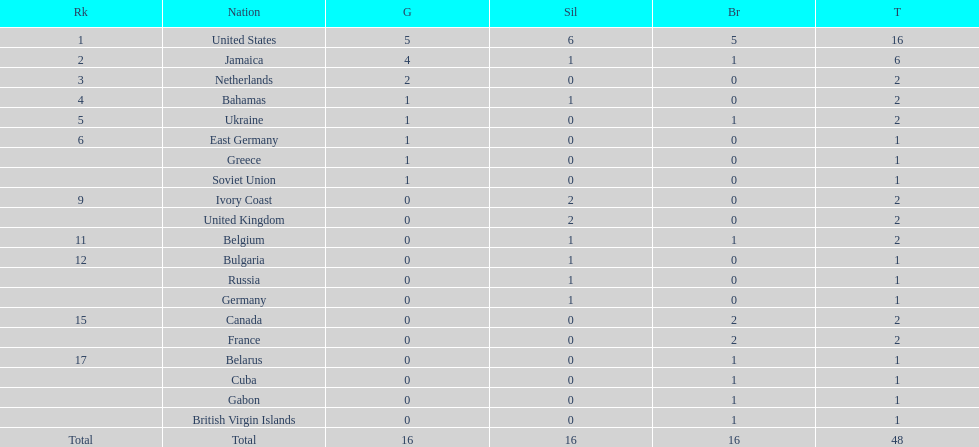What is the average number of gold medals won by the top 5 nations? 2.6. 